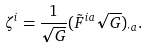<formula> <loc_0><loc_0><loc_500><loc_500>\zeta ^ { i } = \frac { 1 } { \sqrt { G } } ( \tilde { F } ^ { i a } \sqrt { G } ) _ { \cdot a } .</formula> 